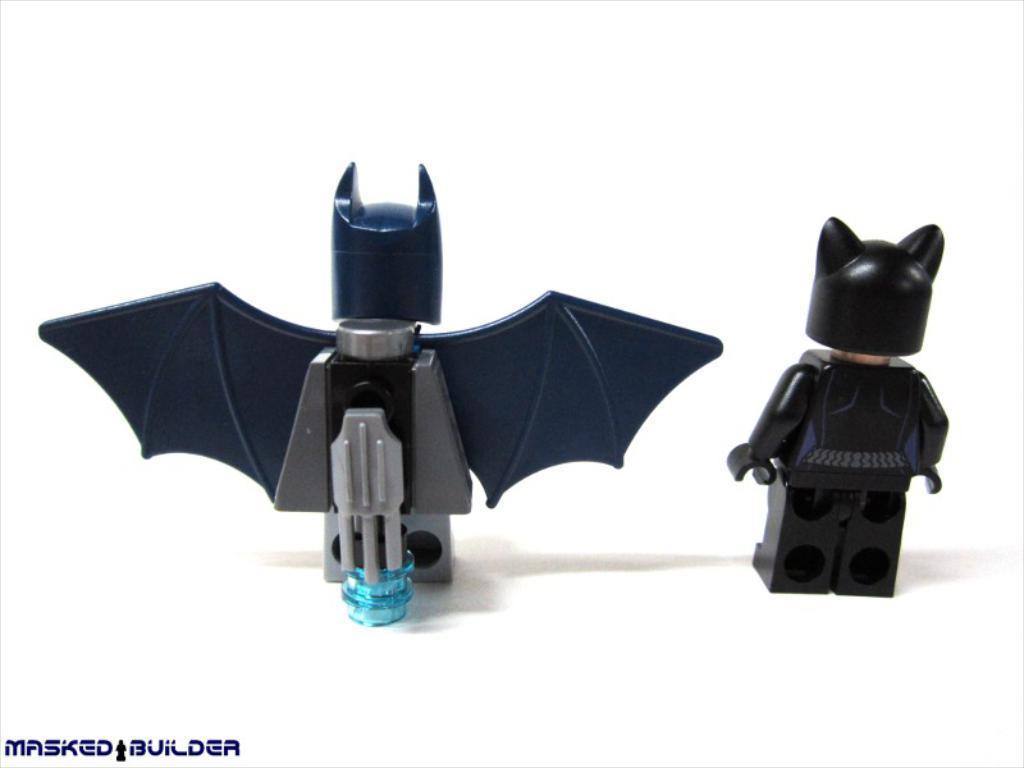Could you give a brief overview of what you see in this image? In this picture we can see couple of toys, in the bottom left hand corner we can see some text. 